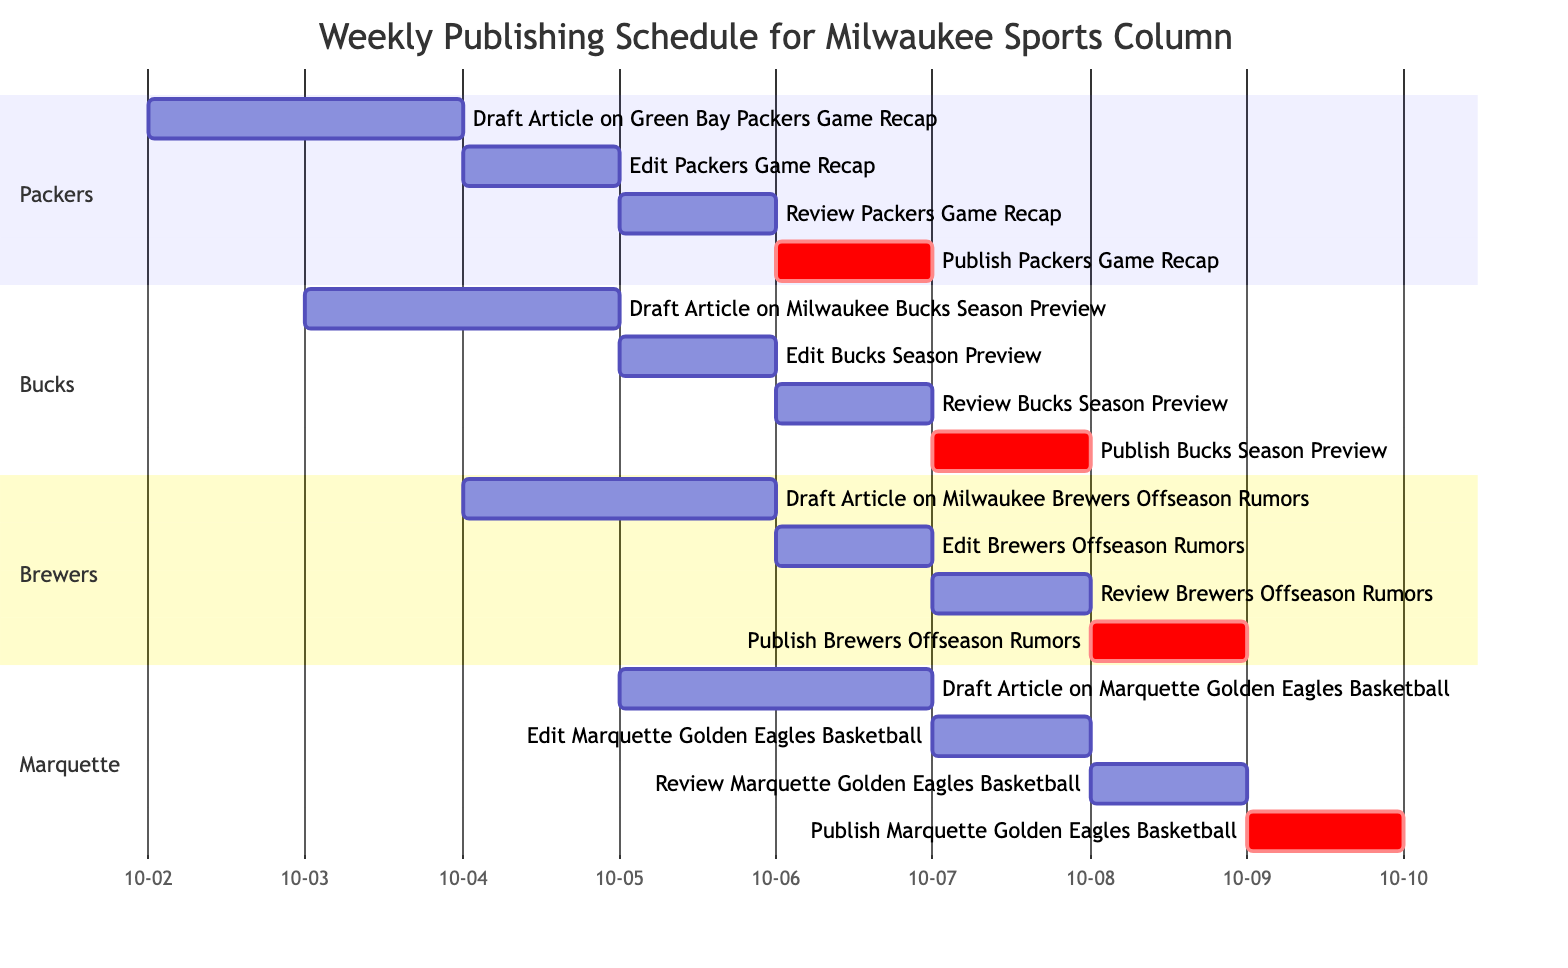What is the starting date for drafting the article on the Green Bay Packers Game Recap? The diagram indicates that the drafting of the Green Bay Packers Game Recap starts on October 2, 2023.
Answer: October 2, 2023 How many total tasks are scheduled for the Milwaukee Bucks Season Preview? By examining the Bucks section of the diagram, we see a total of four tasks: drafting, editing, reviewing, and publishing.
Answer: Four What task is scheduled immediately after the Review of the Packers Game Recap? The diagram shows that the task scheduled immediately after reviewing the Packers Game Recap is the publication of that recap on October 6, 2023.
Answer: Publish Packers Game Recap On what date is the Publishing of the Brewers Offseason Rumors scheduled? Looking at the Brewers section in the diagram, the publication of the Brewers Offseason Rumors is scheduled for October 8, 2023.
Answer: October 8, 2023 Which article's review occurs on October 6, 2023? According to the timeline, the Review of the Bucks Season Preview occurs on October 6, 2023, as shown in the Bucks section of the diagram.
Answer: Review Bucks Season Preview What is the sequence of tasks for the Milwaukee Bucks Season Preview? The sequence of tasks for the Bucks Season Preview includes: Draft -> Edit -> Review -> Publish, as evidenced by the order of tasks in the Gantt Chart.
Answer: Draft, Edit, Review, Publish Which sport has the earliest draft article in the schedule? The earliest draft article is for the Green Bay Packers Game Recap, which starts on October 2, 2023.
Answer: Green Bay Packers How many days are allocated for drafting the Marquette Golden Eagles Basketball article? The diagram indicates that the draft for the Marquette Golden Eagles Basketball article takes two days, from October 5 to October 6, 2023.
Answer: Two days What are the publication dates for all articles listed in the Gantt chart? The publication dates in the Gantt chart are October 6 for the Packers, October 7 for the Bucks, October 8 for the Brewers, and October 9 for Marquette.
Answer: October 6, 7, 8, 9 